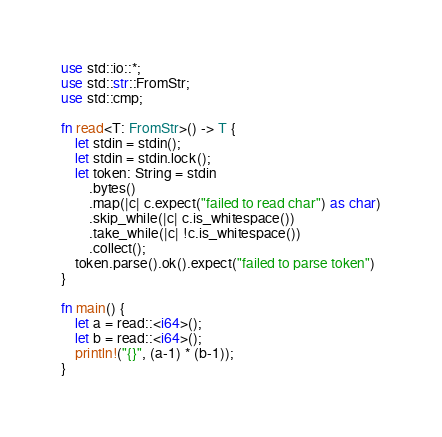<code> <loc_0><loc_0><loc_500><loc_500><_Rust_>use std::io::*;
use std::str::FromStr;
use std::cmp;

fn read<T: FromStr>() -> T {
    let stdin = stdin();
    let stdin = stdin.lock();
    let token: String = stdin
        .bytes()
        .map(|c| c.expect("failed to read char") as char)
        .skip_while(|c| c.is_whitespace())
        .take_while(|c| !c.is_whitespace())
        .collect();
    token.parse().ok().expect("failed to parse token")
}

fn main() {
    let a = read::<i64>();
    let b = read::<i64>();
    println!("{}", (a-1) * (b-1));
}
</code> 